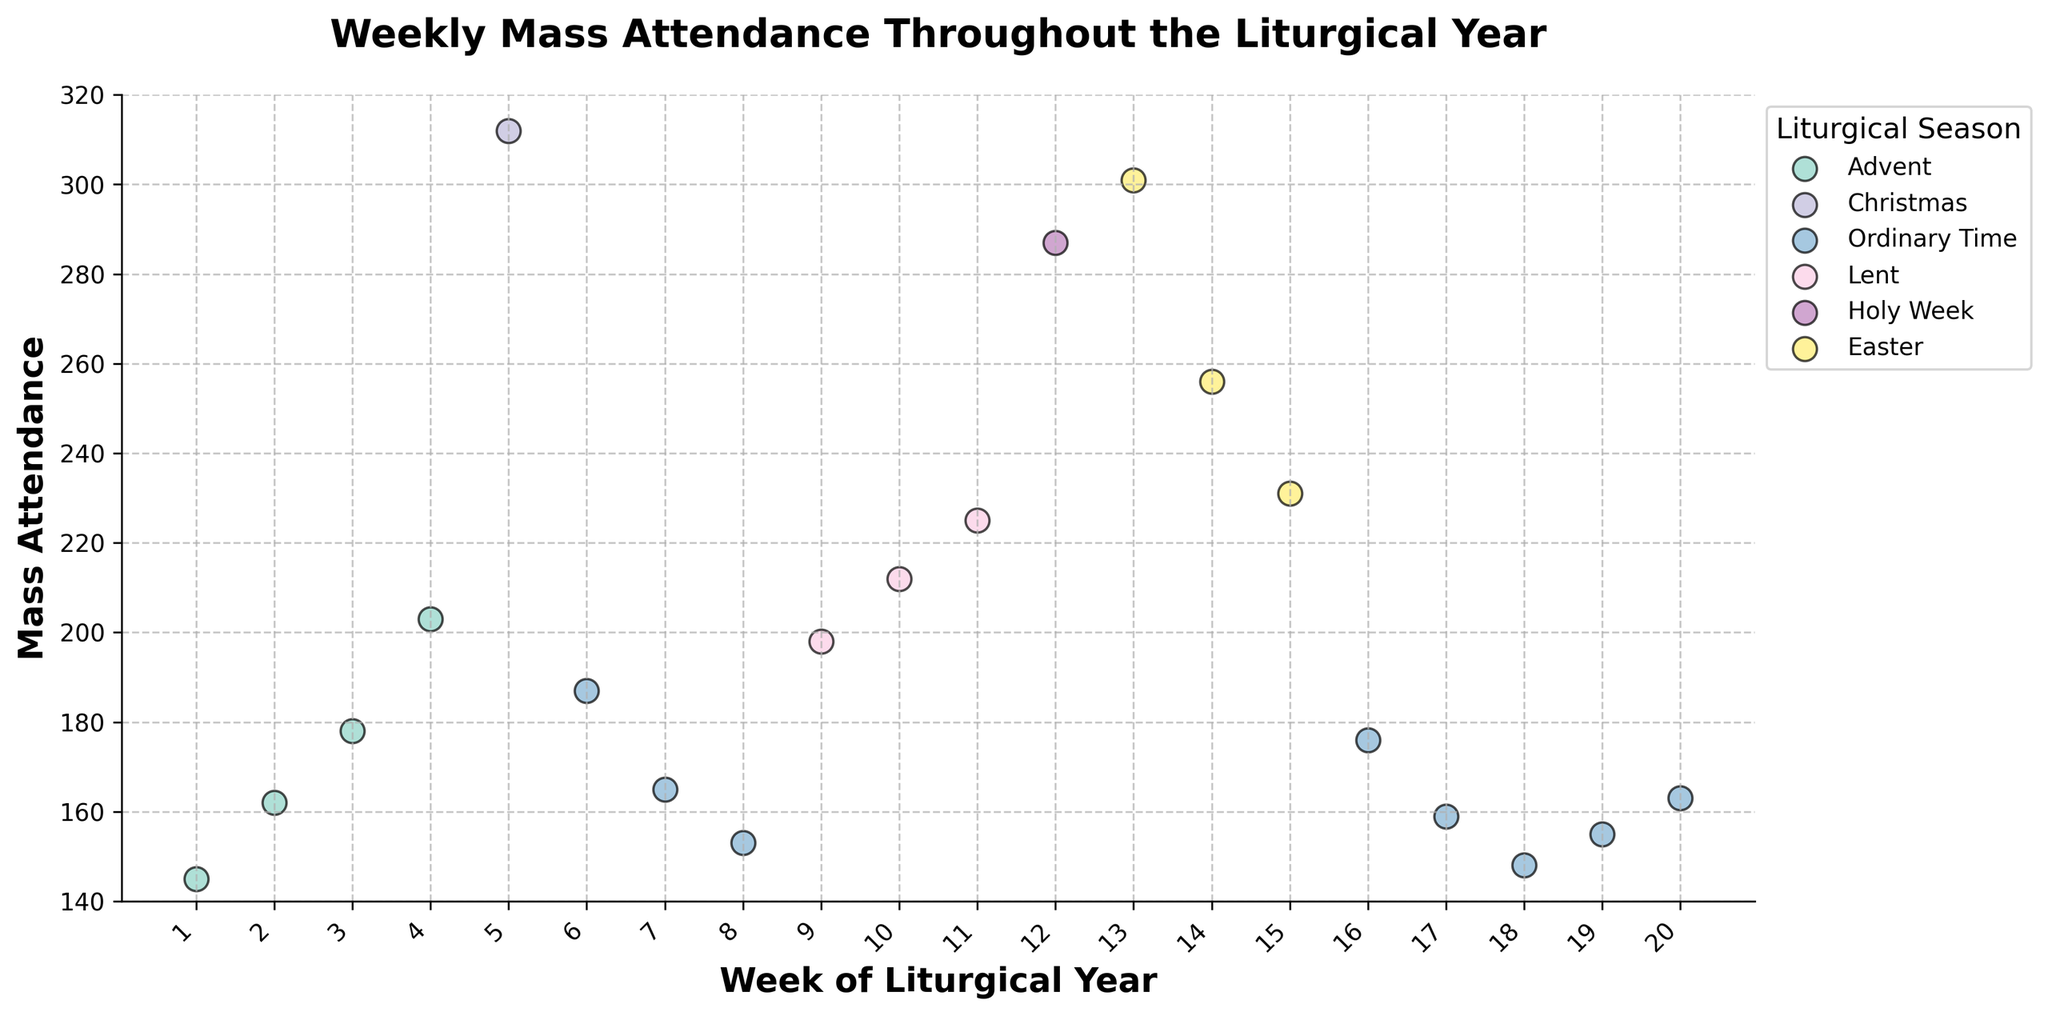What is the title of the figure? The title of the figure is indicated at the top of the chart. It reads, "Weekly Mass Attendance Throughout the Liturgical Year."
Answer: Weekly Mass Attendance Throughout the Liturgical Year In which week does the attendance peak? To identify the peak attendance, locate the highest point on the vertical axis representing "Mass Attendance." The highest value is 312, which occurs during Week 5.
Answer: Week 5 Which season has the largest range of attendance values? By examining the dispersion of data points for each season along the attendance axis, the Advent season appears to have attendance values ranging from 145 to 203, whereas Christmas only covers one week. This suggests Advent has a larger range.
Answer: Advent What is the average attendance during Lent? The attendance values for Lent are 198, 212, and 225. Sum these (198 + 212 + 225 = 635) and divide by the number of weeks (3). The average attendance is 635 / 3 = 211.67.
Answer: 211.67 Which two seasons have the closest average attendance? Calculate average attendance for Advent (average of 145, 162, 178, 203, which is 687/4 = 171.75) and Ordinary Time (average of 187, 165, 153, 176, 159, 148, 155, 163, which is 1306/8 = 163.25). These two averages are closer to each other (171.75 for Advent and 163.25 for Ordinary Time).
Answer: Advent and Ordinary Time During which week of Easter do we see the lowest attendance? Look at the points marked as Easter along the X-axis and find the lowest one. During Easter, the lowest data point is Week 15 with an attendance of 231.
Answer: Week 15 What is the difference in attendance between Holy Week and the following Easter week? Locate the attendance values for Holy Week and the first week of Easter. Holy Week has an attendance of 287, and the following Easter week has 301. The difference is 301 - 287 = 14.
Answer: 14 Is there a trend in attendance during Ordinary Time? By visually examining the points labeled as Ordinary Time, there seems to be a general decrease over the weeks of Ordinary Time, indicating a downward trend.
Answer: Decrease How does attendance during Easter compare to attendance during Advent? Compare the individual points. Easter has attendance values of 301, 256, and 231. Advent values are 145, 162, 178, and 203. Easter generally has higher attendance, especially during the initial weeks of Easter.
Answer: Easter is higher 